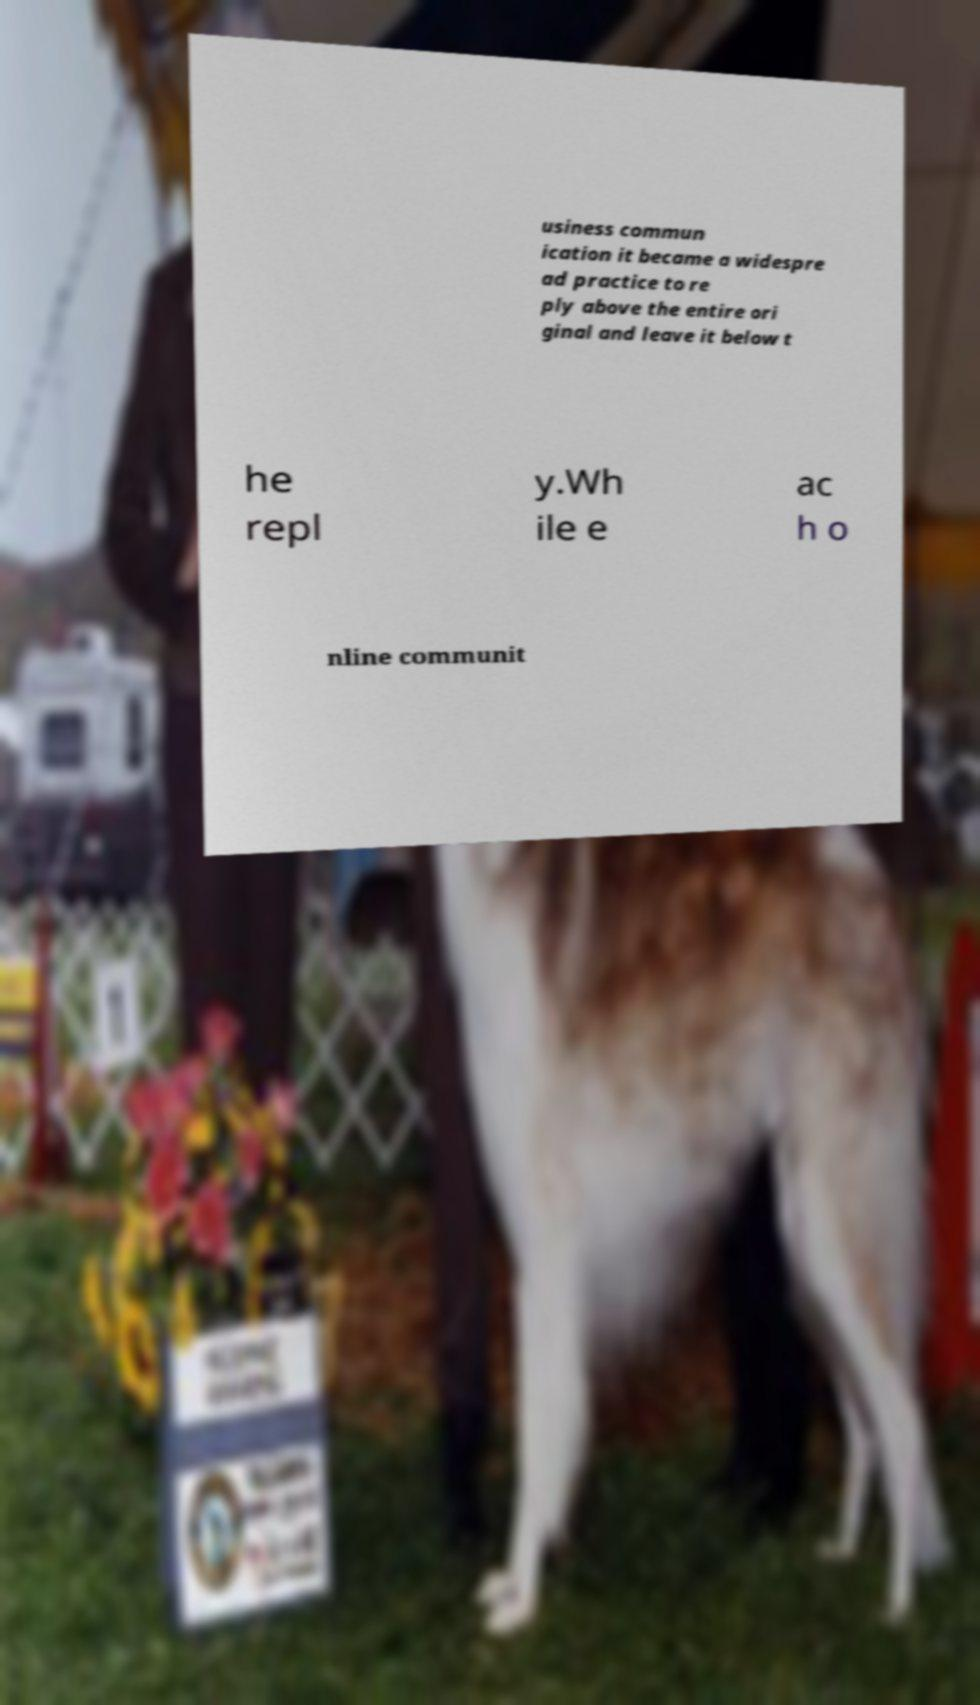Could you extract and type out the text from this image? usiness commun ication it became a widespre ad practice to re ply above the entire ori ginal and leave it below t he repl y.Wh ile e ac h o nline communit 